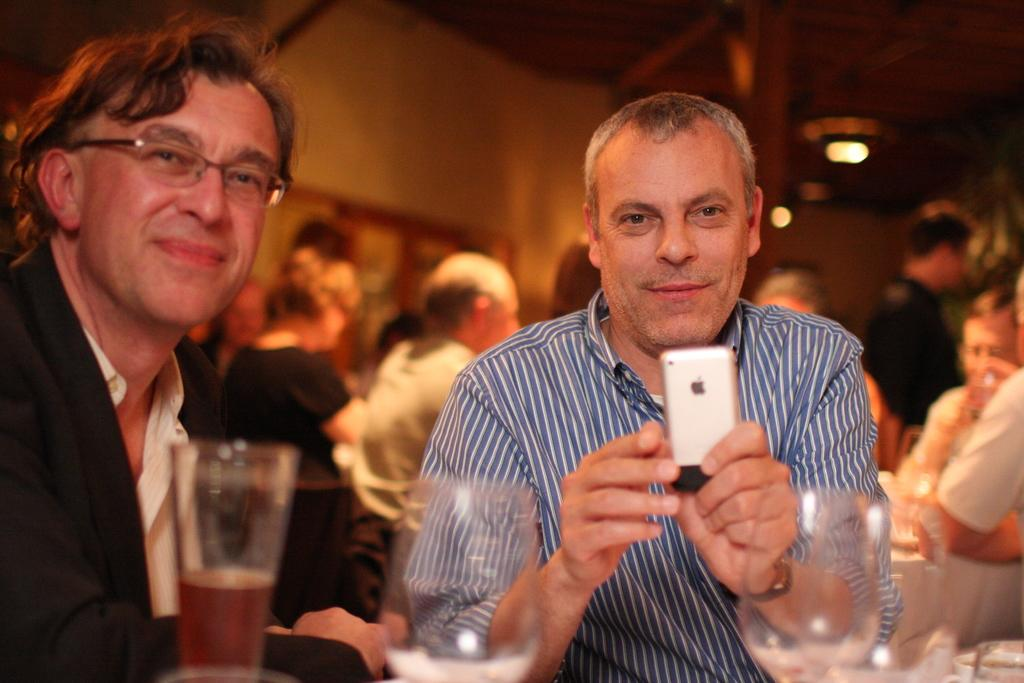Who or what can be seen in the image? There are people in the image. Where are the people located? The people are in a room. What is one person holding in the image? A person is holding a cell phone. What objects are in front of the persons? There are glasses in front of the persons. What type of vacation is the person planning based on the image? There is no indication of a vacation or any planning in the image; it simply shows people in a room with a cell phone and glasses. 